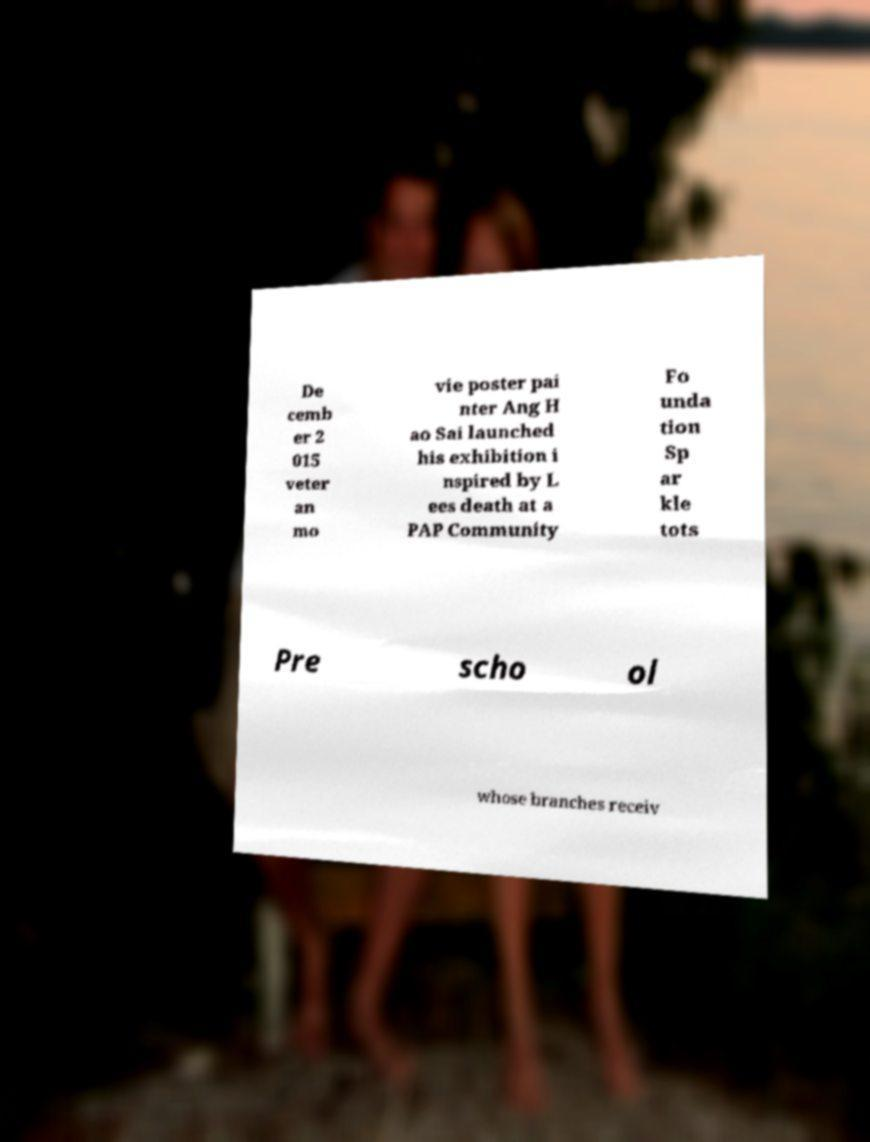What messages or text are displayed in this image? I need them in a readable, typed format. De cemb er 2 015 veter an mo vie poster pai nter Ang H ao Sai launched his exhibition i nspired by L ees death at a PAP Community Fo unda tion Sp ar kle tots Pre scho ol whose branches receiv 